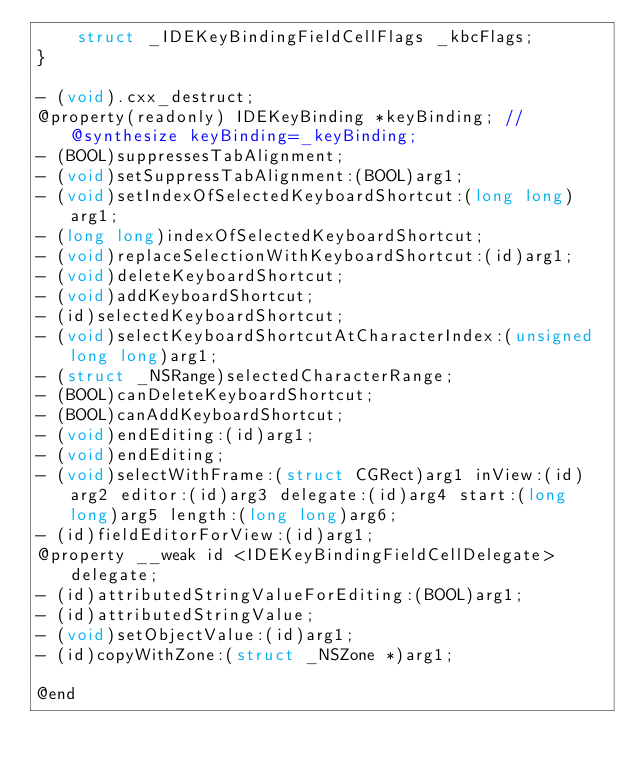<code> <loc_0><loc_0><loc_500><loc_500><_C_>    struct _IDEKeyBindingFieldCellFlags _kbcFlags;
}

- (void).cxx_destruct;
@property(readonly) IDEKeyBinding *keyBinding; // @synthesize keyBinding=_keyBinding;
- (BOOL)suppressesTabAlignment;
- (void)setSuppressTabAlignment:(BOOL)arg1;
- (void)setIndexOfSelectedKeyboardShortcut:(long long)arg1;
- (long long)indexOfSelectedKeyboardShortcut;
- (void)replaceSelectionWithKeyboardShortcut:(id)arg1;
- (void)deleteKeyboardShortcut;
- (void)addKeyboardShortcut;
- (id)selectedKeyboardShortcut;
- (void)selectKeyboardShortcutAtCharacterIndex:(unsigned long long)arg1;
- (struct _NSRange)selectedCharacterRange;
- (BOOL)canDeleteKeyboardShortcut;
- (BOOL)canAddKeyboardShortcut;
- (void)endEditing:(id)arg1;
- (void)endEditing;
- (void)selectWithFrame:(struct CGRect)arg1 inView:(id)arg2 editor:(id)arg3 delegate:(id)arg4 start:(long long)arg5 length:(long long)arg6;
- (id)fieldEditorForView:(id)arg1;
@property __weak id <IDEKeyBindingFieldCellDelegate> delegate;
- (id)attributedStringValueForEditing:(BOOL)arg1;
- (id)attributedStringValue;
- (void)setObjectValue:(id)arg1;
- (id)copyWithZone:(struct _NSZone *)arg1;

@end

</code> 